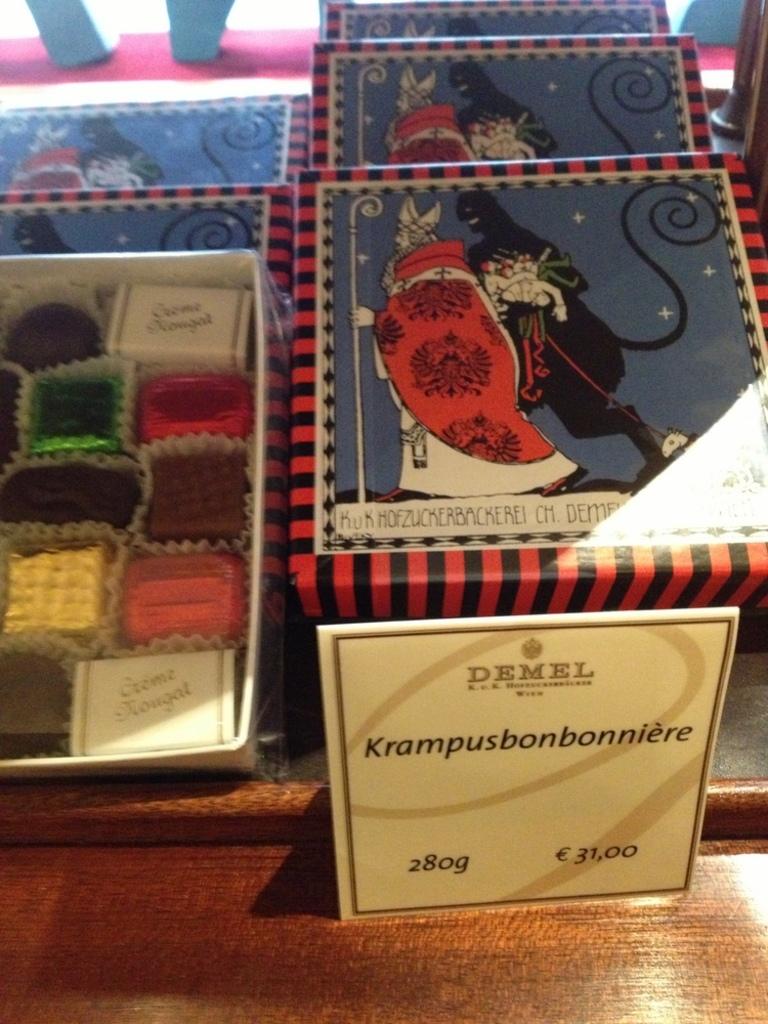How many grams is shown on the sign?
Offer a very short reply. 28. How many euros does this cost?
Ensure brevity in your answer.  31.00. 